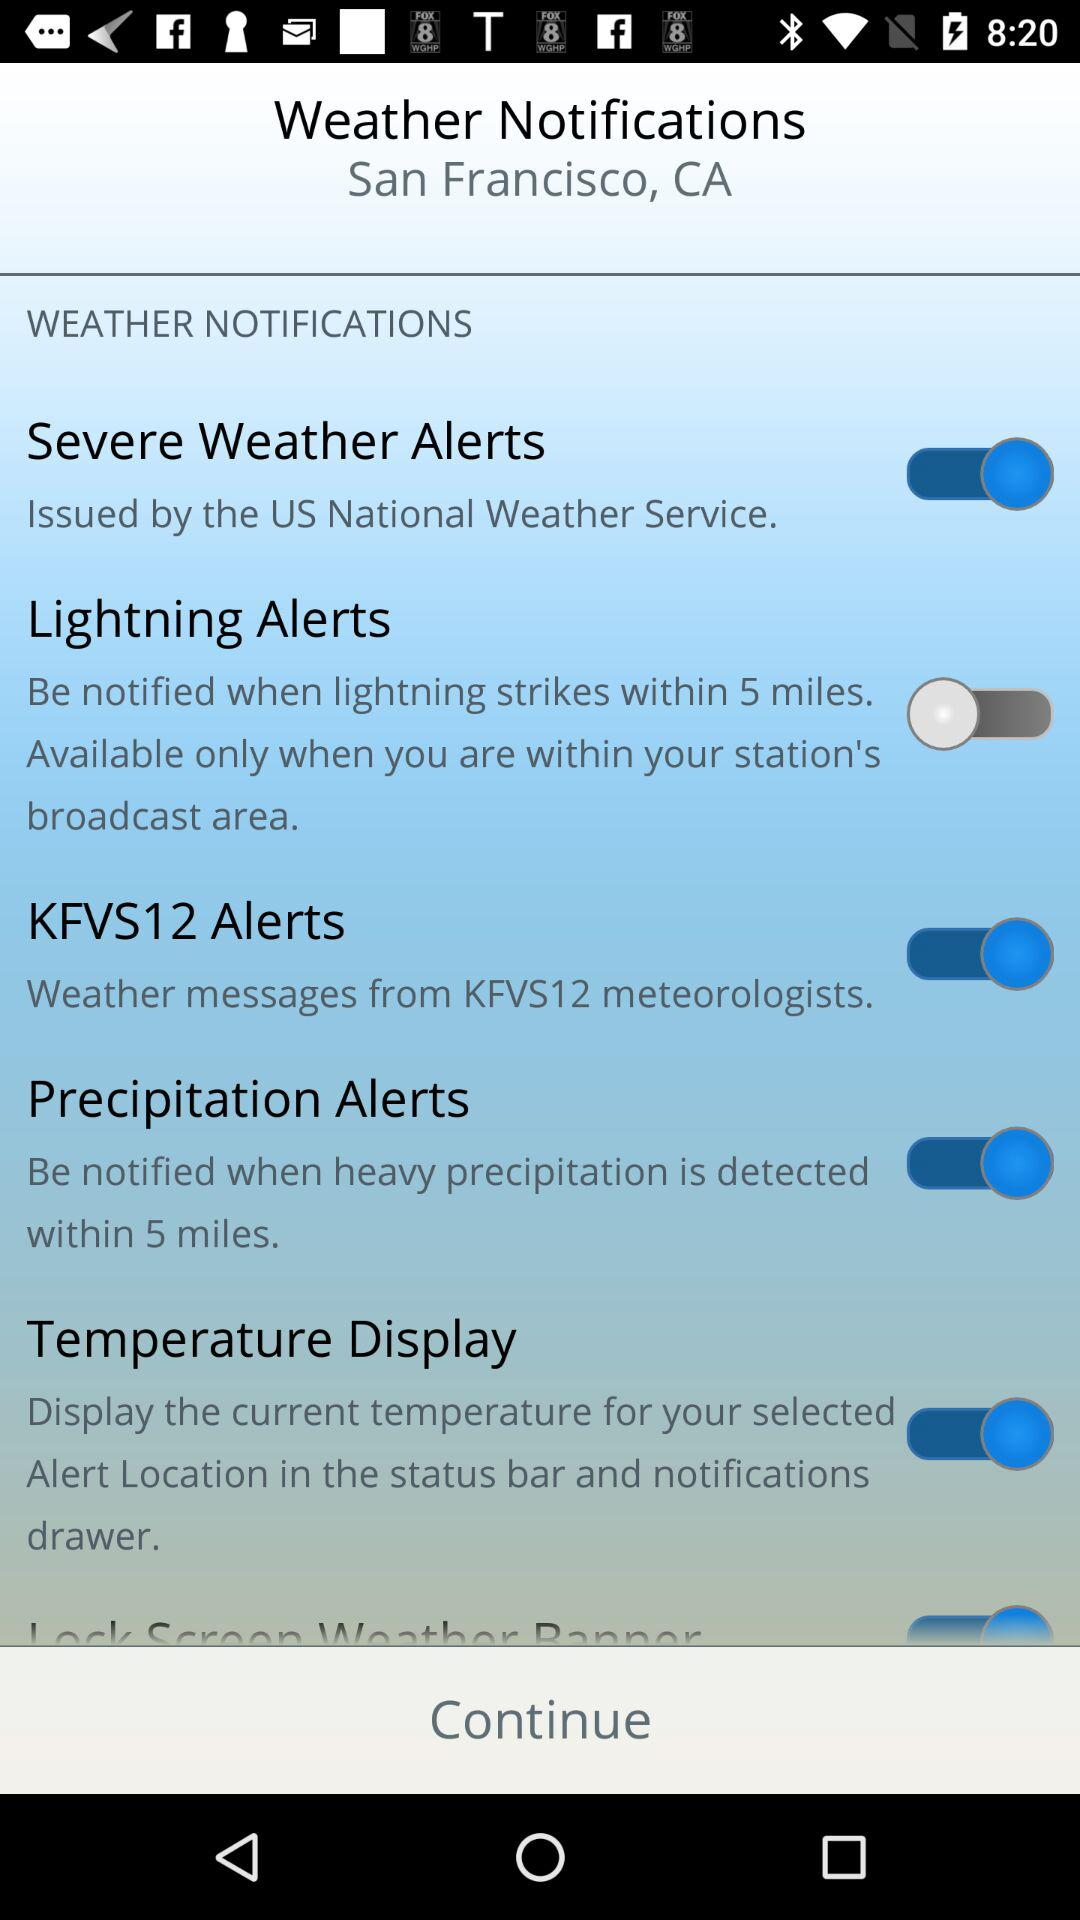What is the status of the "Precipitation Alerts"? The status of the "Precipitation Alerts" is "on". 